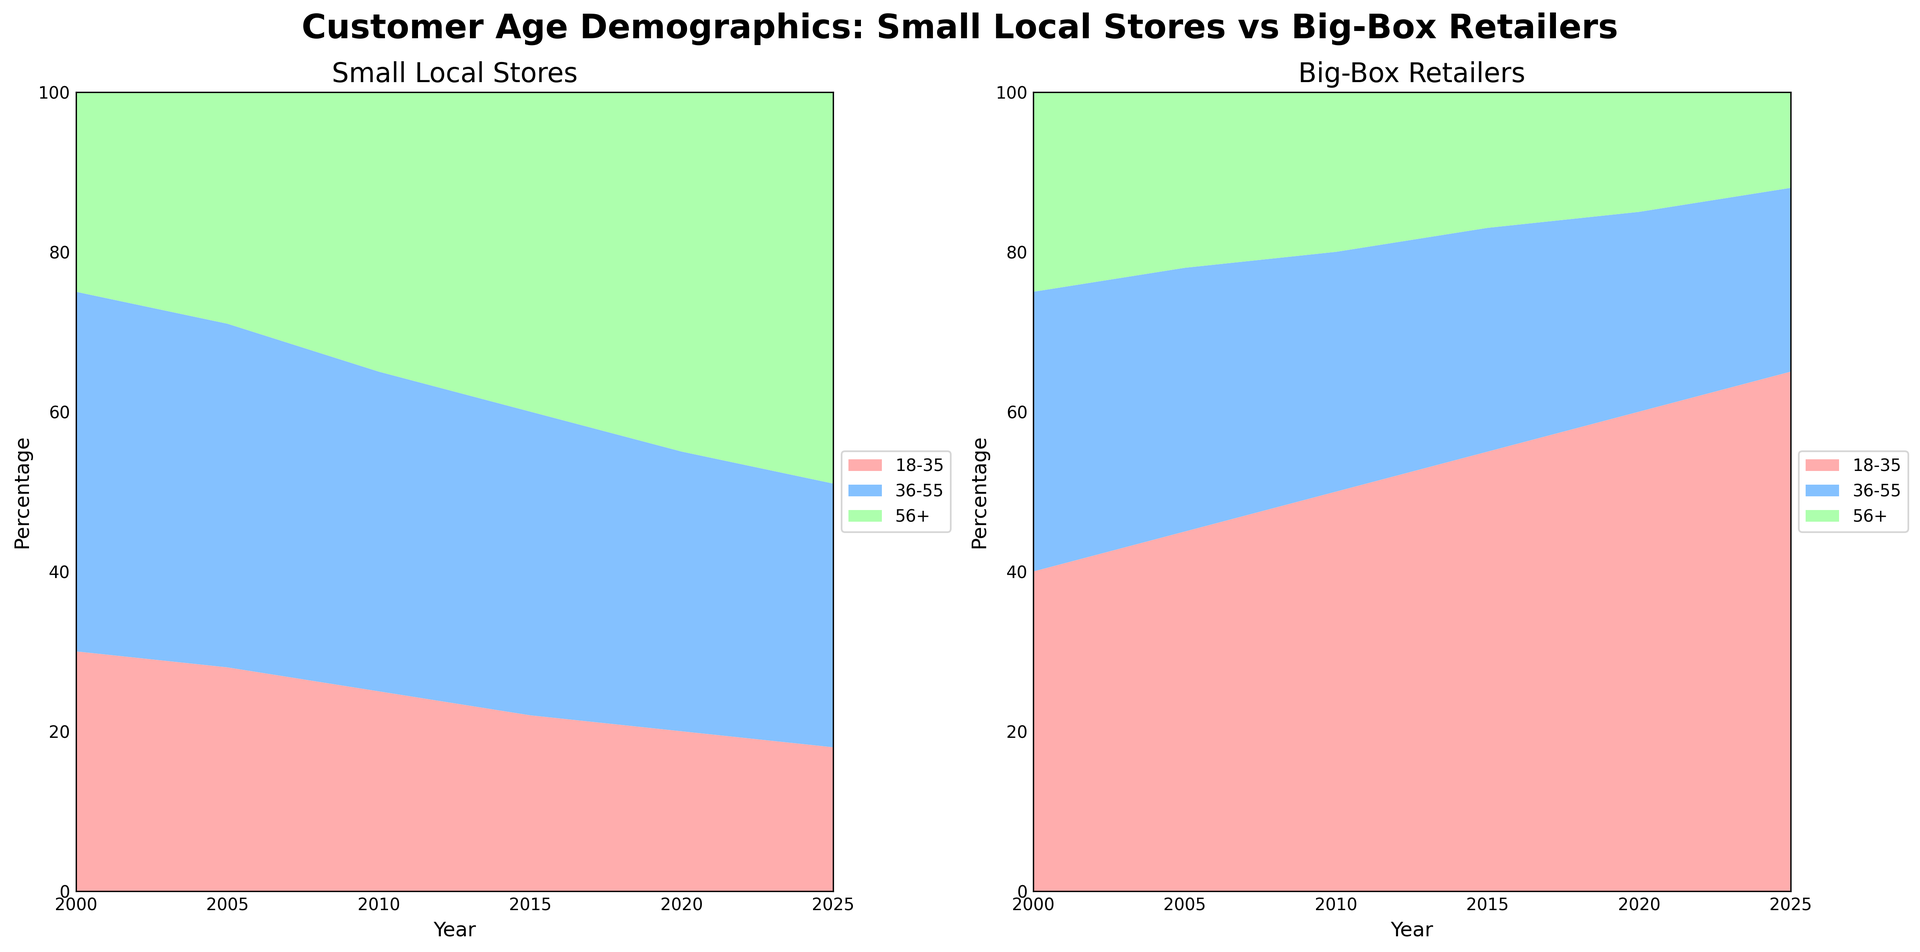What is the trend of the 18-35 age group shopping at small local stores from 2000 to 2025? From the area chart for Small Local Stores, the portion for the 18-35 age group starts at 30% in 2000 and gradually decreases over the years until it reaches 18% in 2025.
Answer: Decreasing What percentage of customers aged 36-55 shopped at big-box retailers in 2010? From the area chart for Big-Box Retailers, the percentage of customers aged 36-55 in 2010 is indicated as 30%.
Answer: 30% Which age group in Small Local Stores increased the most from 2000 to 2025? By examining the area chart for Small Local Stores, the 56+ age group shows an increase from 25% in 2000 to 49% in 2025, the largest increase among the age groups.
Answer: 56+ Compare the percentage of customers aged 18-35 in 2025 between Small Local Stores and Big-Box Retailers. In 2025, the area chart shows that Small Local Stores have 18% of customers aged 18-35, while Big-Box Retailers have 65% of customers aged 18-35.
Answer: Big-Box Retailers have more Is there a consistent trend for the age group 56+ in Big-Box Retailers between 2000 and 2025? Observing the area chart for Big-Box Retailers, the percentage for the age group 56+ consistently decreases from 25% in 2000 to 12% in 2025.
Answer: Decreasing What is the combined percentage of customers aged 36-55 and 56+ shopping at Small Local Stores in 2015? In 2015, Small Local Stores have 38% for the age group 36-55 and 40% for the age group 56+. Adding these together results in 38% + 40% = 78%.
Answer: 78% How does the percentage change for the age group 18-35 in Small Local Stores compare to Big-Box Retailers from 2015 to 2020? From 2015 to 2020, Small Local Stores' 18-35 age group decreases from 22% to 20%, a decrease of 2%. Big-Box Retailers' 18-35 age group increases from 55% to 60%, an increase of 5%.
Answer: Small Local Stores decrease, Big-Box Retailers increase In 2020, which store type has a higher percentage of customers aged 56+? By comparing both area charts for the year 2020, Small Local Stores have 45% and Big-Box Retailers have 15% customers aged 56+.
Answer: Small Local Stores What can you infer about trends in customer age demographics for Big-Box Retailers from 2000 to 2025? Observing the area chart for Big-Box Retailers, the 18-35 age group trend increases from 40% to 65%, the 36-55 age group decreases from 35% to 23%, and the 56+ age group decreases from 25% to 12%. This indicates an increasing trend in younger shoppers and a decreasing trend in older shoppers.
Answer: Younger shoppers increase, older shoppers decrease 